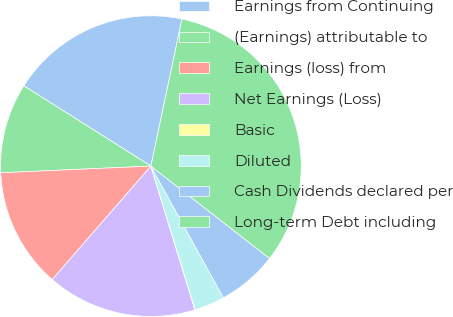Convert chart. <chart><loc_0><loc_0><loc_500><loc_500><pie_chart><fcel>Earnings from Continuing<fcel>(Earnings) attributable to<fcel>Earnings (loss) from<fcel>Net Earnings (Loss)<fcel>Basic<fcel>Diluted<fcel>Cash Dividends declared per<fcel>Long-term Debt including<nl><fcel>19.34%<fcel>9.68%<fcel>12.9%<fcel>16.12%<fcel>0.03%<fcel>3.25%<fcel>6.47%<fcel>32.21%<nl></chart> 